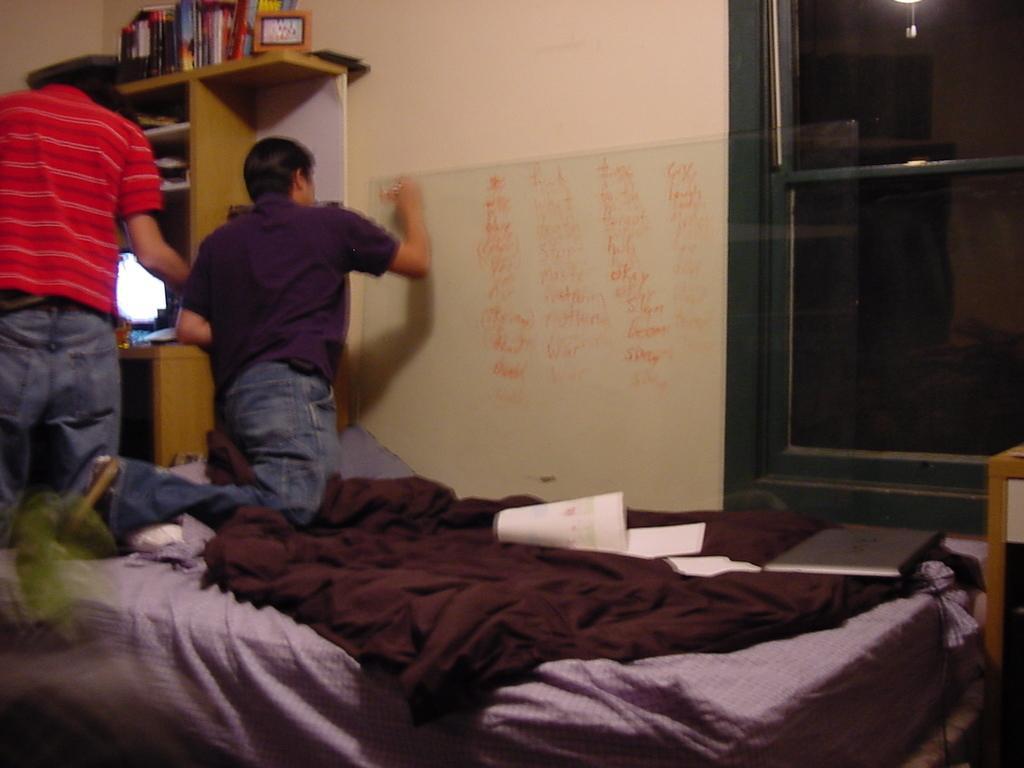Please provide a concise description of this image. this picture shows a man standing and a man writing on the whiteboard with marker and we see a shelf and we see some books,pen stand and a monitor on it and we see blankets and laptop and few papers on the bed and we see a table on the right 